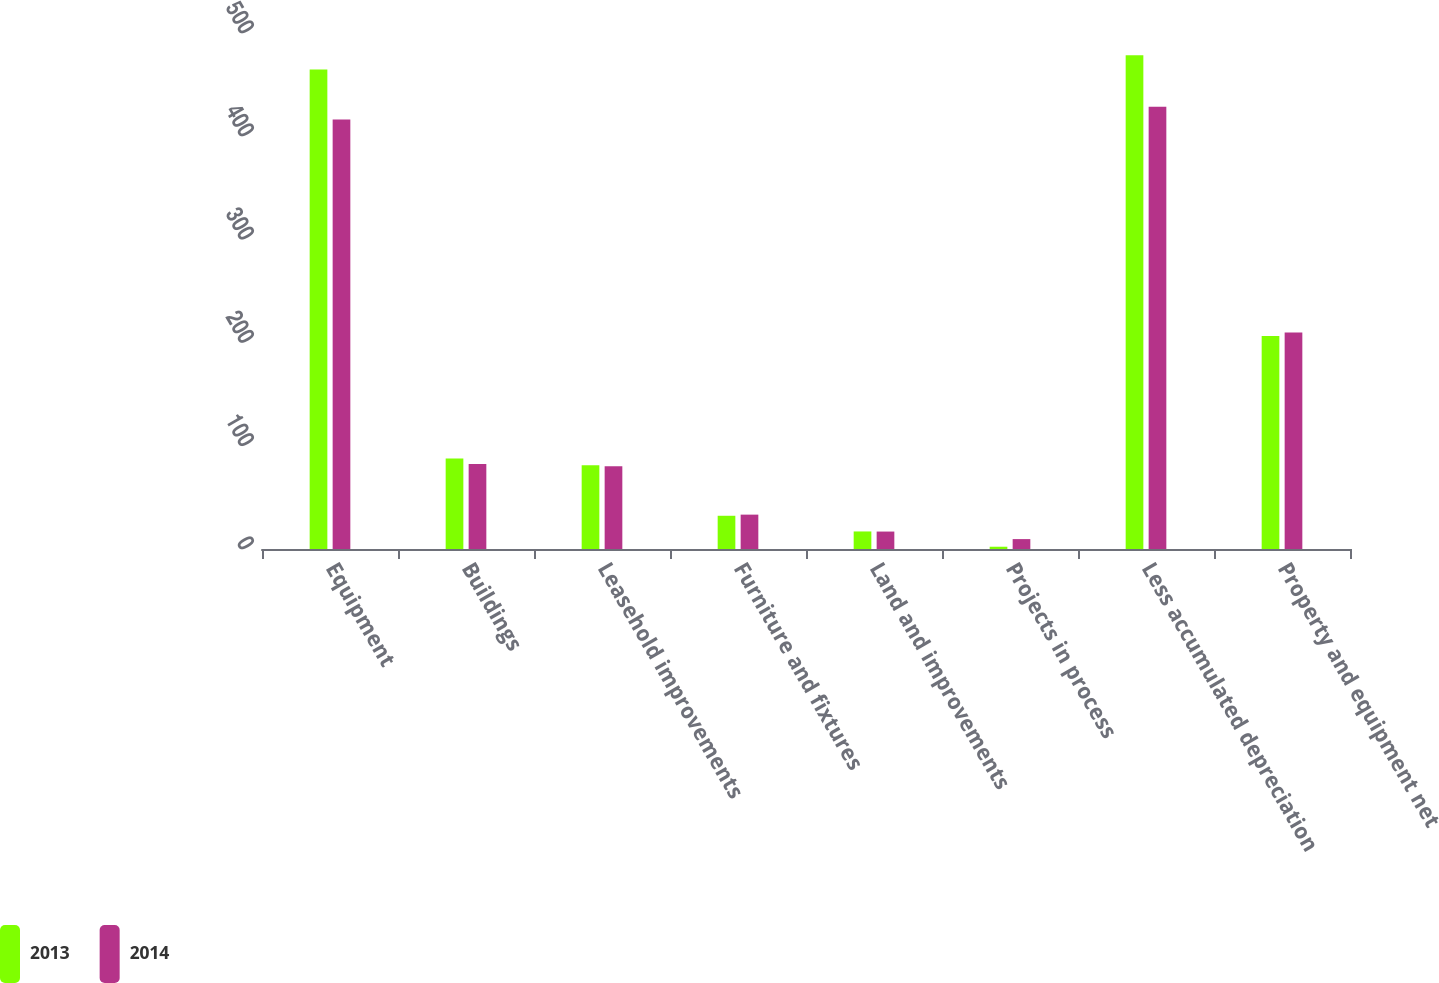<chart> <loc_0><loc_0><loc_500><loc_500><stacked_bar_chart><ecel><fcel>Equipment<fcel>Buildings<fcel>Leasehold improvements<fcel>Furniture and fixtures<fcel>Land and improvements<fcel>Projects in process<fcel>Less accumulated depreciation<fcel>Property and equipment net<nl><fcel>2013<fcel>464.6<fcel>87.8<fcel>81.1<fcel>32.2<fcel>17<fcel>2.2<fcel>478.5<fcel>206.4<nl><fcel>2014<fcel>416.1<fcel>82.3<fcel>80.3<fcel>33.3<fcel>16.9<fcel>9.6<fcel>428.6<fcel>209.9<nl></chart> 